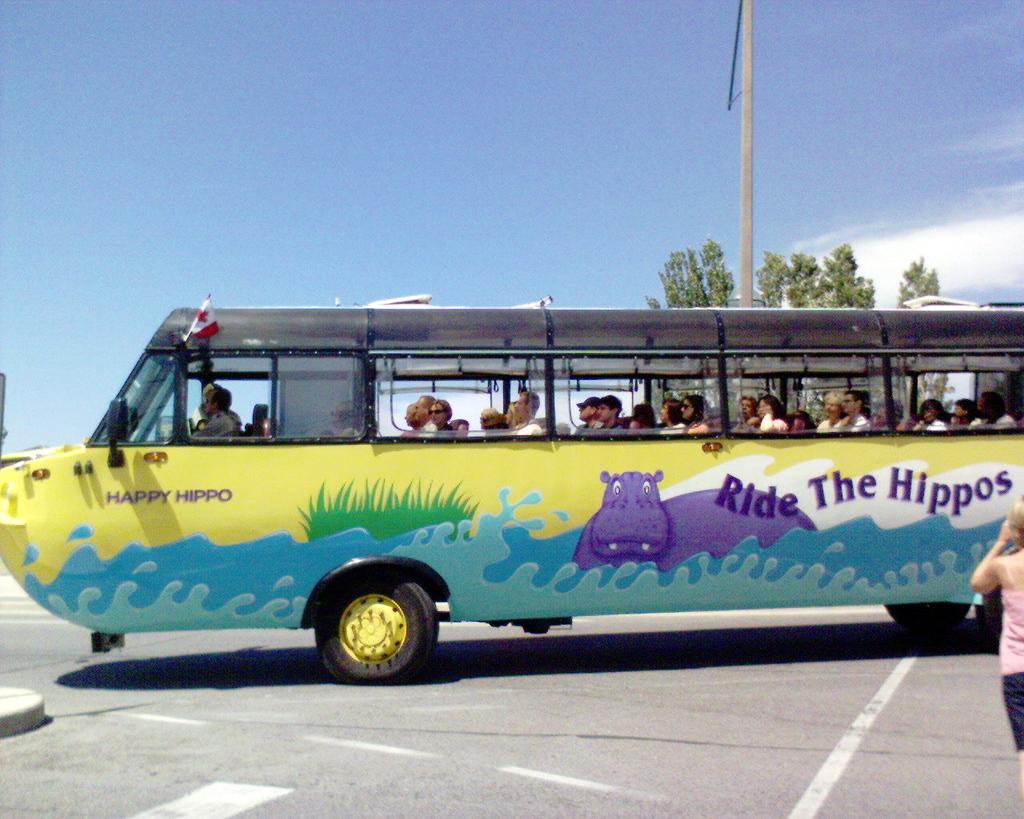Right the what?
Offer a terse response. Hippos. What are the two words on the front of the bus?
Your answer should be very brief. Happy hippo. 